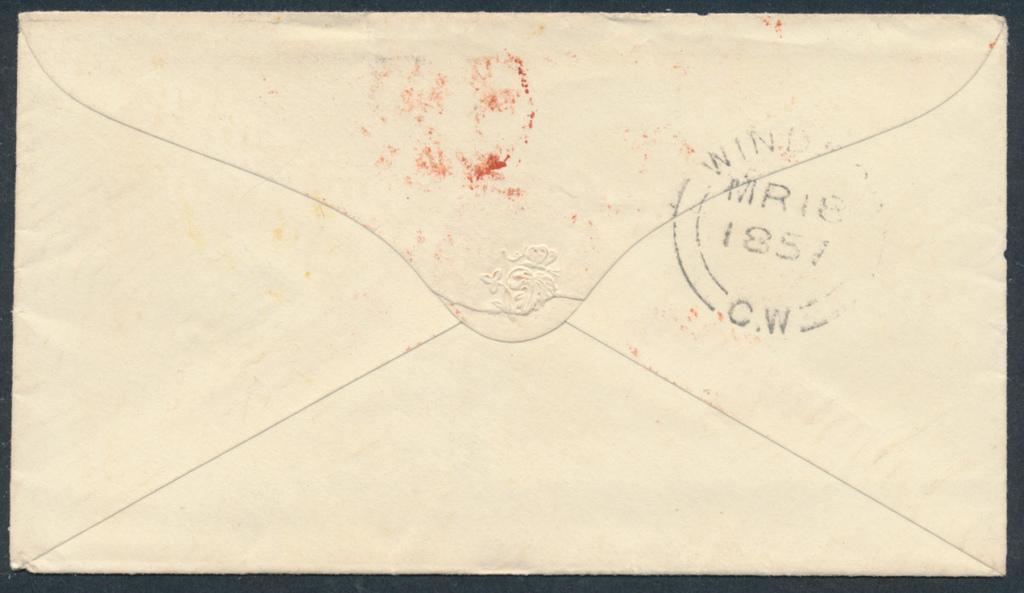<image>
Present a compact description of the photo's key features. The back of an enveloped has a stamp, dated 1857. 